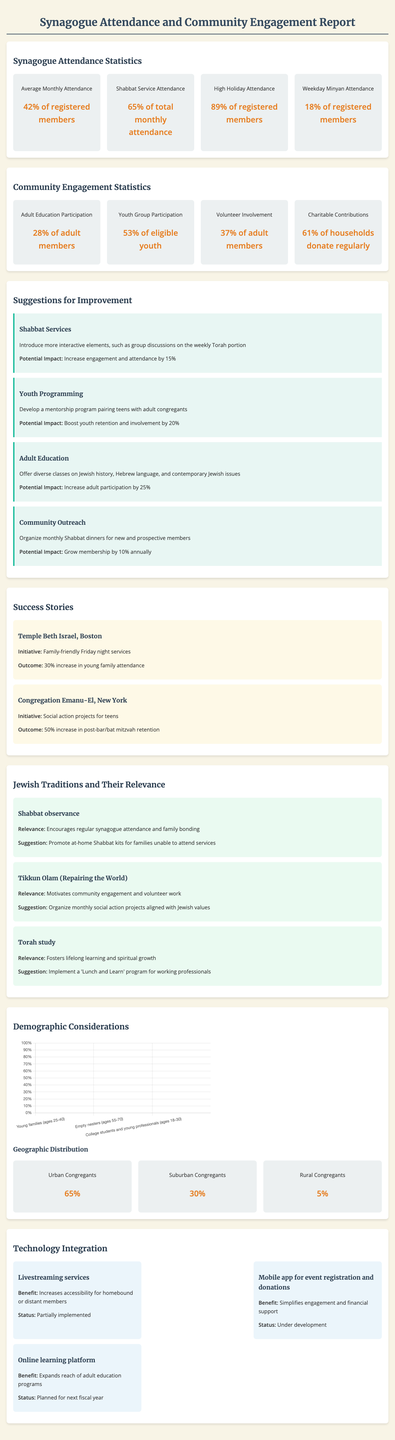what is the average monthly attendance? The average monthly attendance is given as a percentage of registered members, which is 42%.
Answer: 42% what percentage of members attended high holidays? High holiday attendance includes 89% of registered members.
Answer: 89% what is the youth group participation rate? Youth group participation is specified as the percentage of eligible youth participating, which is 53%.
Answer: 53% how many adult members participate in volunteer activities? Volunteer involvement among adult members is recorded at 37%.
Answer: 37% what suggestion is made to improve Shabbat services? The suggestion for Shabbat services is to introduce more interactive elements, such as group discussions on the weekly Torah portion.
Answer: Introduce more interactive elements what impact is expected from improving adult education? The potential impact of improving adult education is an increase in adult participation by 25%.
Answer: Increase by 25% which synagogue had a success story related to family-friendly services? Temple Beth Israel in Boston is cited for its initiative involving family-friendly Friday night services.
Answer: Temple Beth Israel, Boston how does Tikkun Olam relate to community engagement? Tikkun Olam is associated with motivating community engagement and volunteer work.
Answer: Motivates community engagement what demographic group currently has the highest engagement? The empty nesters group (ages 55-70) shows the highest current engagement rate at 58%.
Answer: 58% 